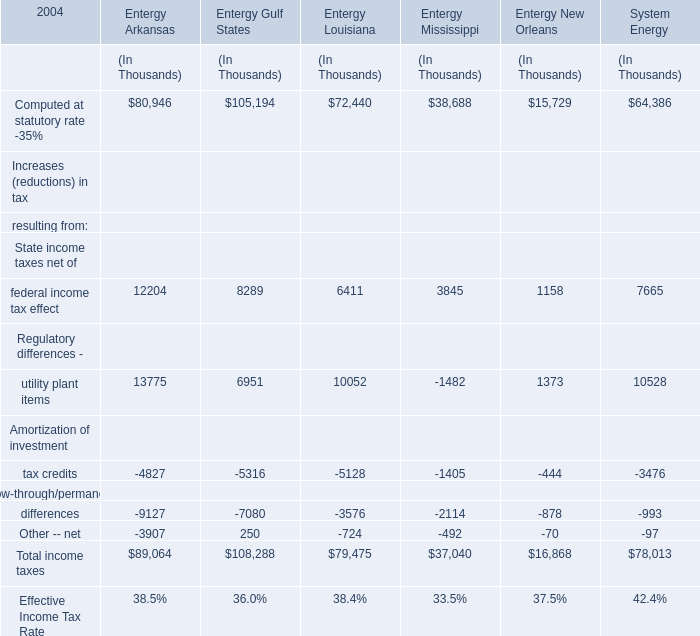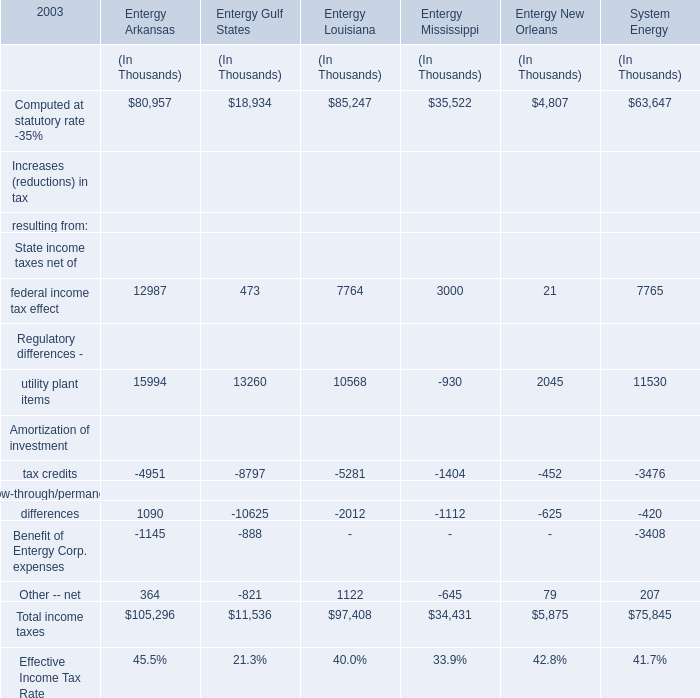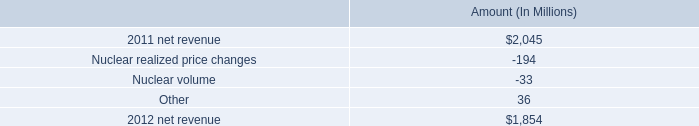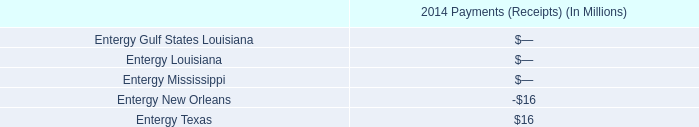What's the sum of all income taxes that are positive for Entergy Arkansas? (in Dollars In Thousands) 
Computations: ((((80957 + 12987) + 15994) + 1090) + 364)
Answer: 111392.0. 